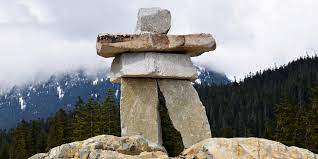What is the historical or cultural significance of Inukshuks? Inukshuks hold profound cultural value for the Inuit people. Historically, they have been used not just for navigation, but also as symbols of communication and survival, integral to the nomadic lifestyles of the Inuit. They signal safety, hunting grounds, or caches of food or supplies. Symbolically, they represent hope, friendship, and guidance, acting as silent keepers of the land that convey the resilient spirit of the Inuit people across generations. 